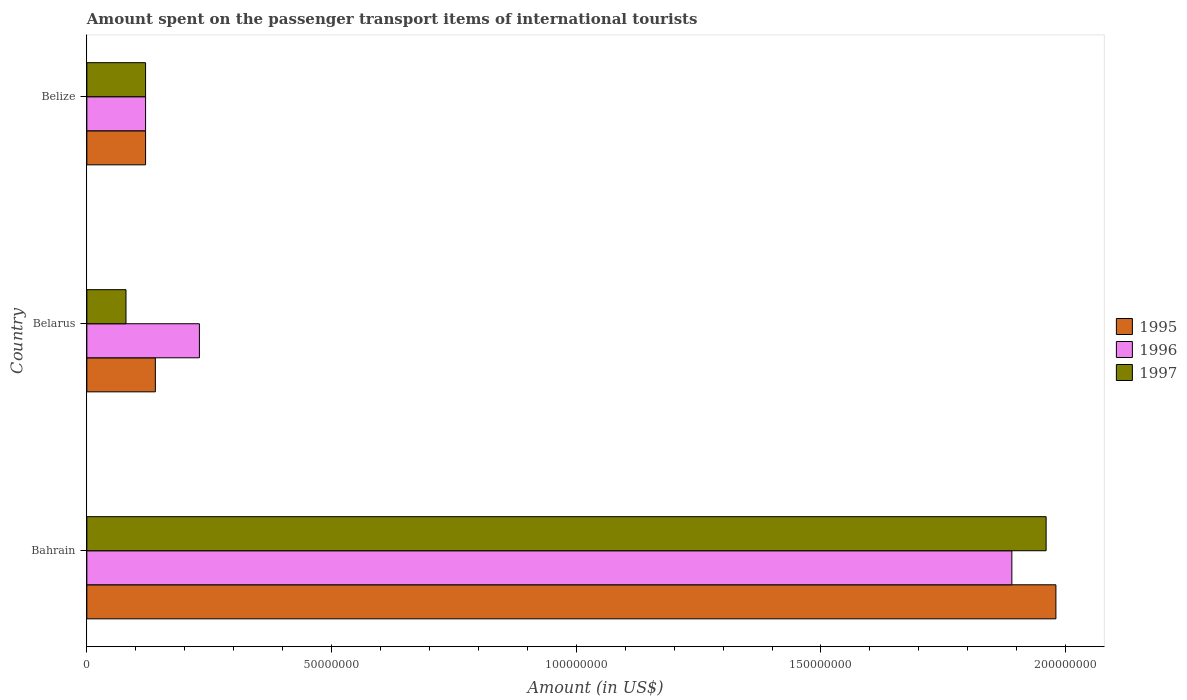How many groups of bars are there?
Your answer should be very brief. 3. Are the number of bars per tick equal to the number of legend labels?
Provide a succinct answer. Yes. Are the number of bars on each tick of the Y-axis equal?
Provide a short and direct response. Yes. How many bars are there on the 3rd tick from the bottom?
Offer a very short reply. 3. What is the label of the 1st group of bars from the top?
Provide a short and direct response. Belize. What is the amount spent on the passenger transport items of international tourists in 1997 in Belize?
Ensure brevity in your answer.  1.20e+07. Across all countries, what is the maximum amount spent on the passenger transport items of international tourists in 1995?
Make the answer very short. 1.98e+08. In which country was the amount spent on the passenger transport items of international tourists in 1997 maximum?
Ensure brevity in your answer.  Bahrain. In which country was the amount spent on the passenger transport items of international tourists in 1996 minimum?
Your answer should be compact. Belize. What is the total amount spent on the passenger transport items of international tourists in 1995 in the graph?
Make the answer very short. 2.24e+08. What is the difference between the amount spent on the passenger transport items of international tourists in 1997 in Bahrain and that in Belarus?
Give a very brief answer. 1.88e+08. What is the difference between the amount spent on the passenger transport items of international tourists in 1997 in Belize and the amount spent on the passenger transport items of international tourists in 1996 in Bahrain?
Provide a succinct answer. -1.77e+08. What is the average amount spent on the passenger transport items of international tourists in 1997 per country?
Your answer should be compact. 7.20e+07. What is the difference between the amount spent on the passenger transport items of international tourists in 1995 and amount spent on the passenger transport items of international tourists in 1996 in Belize?
Your answer should be compact. 0. What is the ratio of the amount spent on the passenger transport items of international tourists in 1997 in Belarus to that in Belize?
Keep it short and to the point. 0.67. Is the amount spent on the passenger transport items of international tourists in 1997 in Bahrain less than that in Belarus?
Offer a very short reply. No. Is the difference between the amount spent on the passenger transport items of international tourists in 1995 in Belarus and Belize greater than the difference between the amount spent on the passenger transport items of international tourists in 1996 in Belarus and Belize?
Your answer should be very brief. No. What is the difference between the highest and the second highest amount spent on the passenger transport items of international tourists in 1997?
Provide a succinct answer. 1.84e+08. What is the difference between the highest and the lowest amount spent on the passenger transport items of international tourists in 1995?
Make the answer very short. 1.86e+08. Is the sum of the amount spent on the passenger transport items of international tourists in 1997 in Bahrain and Belize greater than the maximum amount spent on the passenger transport items of international tourists in 1996 across all countries?
Provide a succinct answer. Yes. What does the 2nd bar from the top in Belize represents?
Ensure brevity in your answer.  1996. Are all the bars in the graph horizontal?
Offer a terse response. Yes. How many countries are there in the graph?
Provide a succinct answer. 3. What is the difference between two consecutive major ticks on the X-axis?
Give a very brief answer. 5.00e+07. Are the values on the major ticks of X-axis written in scientific E-notation?
Give a very brief answer. No. Does the graph contain any zero values?
Offer a very short reply. No. Where does the legend appear in the graph?
Give a very brief answer. Center right. How are the legend labels stacked?
Ensure brevity in your answer.  Vertical. What is the title of the graph?
Keep it short and to the point. Amount spent on the passenger transport items of international tourists. Does "1983" appear as one of the legend labels in the graph?
Keep it short and to the point. No. What is the label or title of the X-axis?
Make the answer very short. Amount (in US$). What is the Amount (in US$) in 1995 in Bahrain?
Your answer should be compact. 1.98e+08. What is the Amount (in US$) of 1996 in Bahrain?
Provide a succinct answer. 1.89e+08. What is the Amount (in US$) in 1997 in Bahrain?
Give a very brief answer. 1.96e+08. What is the Amount (in US$) of 1995 in Belarus?
Provide a succinct answer. 1.40e+07. What is the Amount (in US$) of 1996 in Belarus?
Provide a short and direct response. 2.30e+07. What is the Amount (in US$) in 1997 in Belarus?
Make the answer very short. 8.00e+06. What is the Amount (in US$) of 1995 in Belize?
Provide a short and direct response. 1.20e+07. What is the Amount (in US$) of 1996 in Belize?
Your response must be concise. 1.20e+07. Across all countries, what is the maximum Amount (in US$) of 1995?
Make the answer very short. 1.98e+08. Across all countries, what is the maximum Amount (in US$) of 1996?
Provide a short and direct response. 1.89e+08. Across all countries, what is the maximum Amount (in US$) of 1997?
Your response must be concise. 1.96e+08. Across all countries, what is the minimum Amount (in US$) in 1996?
Offer a terse response. 1.20e+07. What is the total Amount (in US$) of 1995 in the graph?
Keep it short and to the point. 2.24e+08. What is the total Amount (in US$) in 1996 in the graph?
Your response must be concise. 2.24e+08. What is the total Amount (in US$) in 1997 in the graph?
Your answer should be very brief. 2.16e+08. What is the difference between the Amount (in US$) of 1995 in Bahrain and that in Belarus?
Make the answer very short. 1.84e+08. What is the difference between the Amount (in US$) of 1996 in Bahrain and that in Belarus?
Ensure brevity in your answer.  1.66e+08. What is the difference between the Amount (in US$) of 1997 in Bahrain and that in Belarus?
Your response must be concise. 1.88e+08. What is the difference between the Amount (in US$) in 1995 in Bahrain and that in Belize?
Give a very brief answer. 1.86e+08. What is the difference between the Amount (in US$) of 1996 in Bahrain and that in Belize?
Your response must be concise. 1.77e+08. What is the difference between the Amount (in US$) in 1997 in Bahrain and that in Belize?
Ensure brevity in your answer.  1.84e+08. What is the difference between the Amount (in US$) in 1995 in Belarus and that in Belize?
Offer a very short reply. 2.00e+06. What is the difference between the Amount (in US$) in 1996 in Belarus and that in Belize?
Make the answer very short. 1.10e+07. What is the difference between the Amount (in US$) in 1995 in Bahrain and the Amount (in US$) in 1996 in Belarus?
Provide a short and direct response. 1.75e+08. What is the difference between the Amount (in US$) of 1995 in Bahrain and the Amount (in US$) of 1997 in Belarus?
Provide a succinct answer. 1.90e+08. What is the difference between the Amount (in US$) in 1996 in Bahrain and the Amount (in US$) in 1997 in Belarus?
Make the answer very short. 1.81e+08. What is the difference between the Amount (in US$) of 1995 in Bahrain and the Amount (in US$) of 1996 in Belize?
Provide a succinct answer. 1.86e+08. What is the difference between the Amount (in US$) of 1995 in Bahrain and the Amount (in US$) of 1997 in Belize?
Keep it short and to the point. 1.86e+08. What is the difference between the Amount (in US$) of 1996 in Bahrain and the Amount (in US$) of 1997 in Belize?
Make the answer very short. 1.77e+08. What is the difference between the Amount (in US$) in 1996 in Belarus and the Amount (in US$) in 1997 in Belize?
Provide a succinct answer. 1.10e+07. What is the average Amount (in US$) in 1995 per country?
Offer a terse response. 7.47e+07. What is the average Amount (in US$) of 1996 per country?
Your answer should be very brief. 7.47e+07. What is the average Amount (in US$) of 1997 per country?
Provide a short and direct response. 7.20e+07. What is the difference between the Amount (in US$) in 1995 and Amount (in US$) in 1996 in Bahrain?
Make the answer very short. 9.00e+06. What is the difference between the Amount (in US$) of 1996 and Amount (in US$) of 1997 in Bahrain?
Make the answer very short. -7.00e+06. What is the difference between the Amount (in US$) in 1995 and Amount (in US$) in 1996 in Belarus?
Your response must be concise. -9.00e+06. What is the difference between the Amount (in US$) of 1995 and Amount (in US$) of 1997 in Belarus?
Make the answer very short. 6.00e+06. What is the difference between the Amount (in US$) of 1996 and Amount (in US$) of 1997 in Belarus?
Your answer should be compact. 1.50e+07. What is the difference between the Amount (in US$) in 1995 and Amount (in US$) in 1996 in Belize?
Your answer should be compact. 0. What is the difference between the Amount (in US$) in 1995 and Amount (in US$) in 1997 in Belize?
Your answer should be very brief. 0. What is the difference between the Amount (in US$) in 1996 and Amount (in US$) in 1997 in Belize?
Provide a succinct answer. 0. What is the ratio of the Amount (in US$) in 1995 in Bahrain to that in Belarus?
Offer a terse response. 14.14. What is the ratio of the Amount (in US$) of 1996 in Bahrain to that in Belarus?
Give a very brief answer. 8.22. What is the ratio of the Amount (in US$) in 1996 in Bahrain to that in Belize?
Provide a short and direct response. 15.75. What is the ratio of the Amount (in US$) in 1997 in Bahrain to that in Belize?
Offer a terse response. 16.33. What is the ratio of the Amount (in US$) of 1995 in Belarus to that in Belize?
Offer a very short reply. 1.17. What is the ratio of the Amount (in US$) in 1996 in Belarus to that in Belize?
Your response must be concise. 1.92. What is the ratio of the Amount (in US$) of 1997 in Belarus to that in Belize?
Ensure brevity in your answer.  0.67. What is the difference between the highest and the second highest Amount (in US$) in 1995?
Your answer should be very brief. 1.84e+08. What is the difference between the highest and the second highest Amount (in US$) of 1996?
Provide a short and direct response. 1.66e+08. What is the difference between the highest and the second highest Amount (in US$) of 1997?
Give a very brief answer. 1.84e+08. What is the difference between the highest and the lowest Amount (in US$) of 1995?
Your answer should be very brief. 1.86e+08. What is the difference between the highest and the lowest Amount (in US$) in 1996?
Offer a terse response. 1.77e+08. What is the difference between the highest and the lowest Amount (in US$) in 1997?
Offer a terse response. 1.88e+08. 